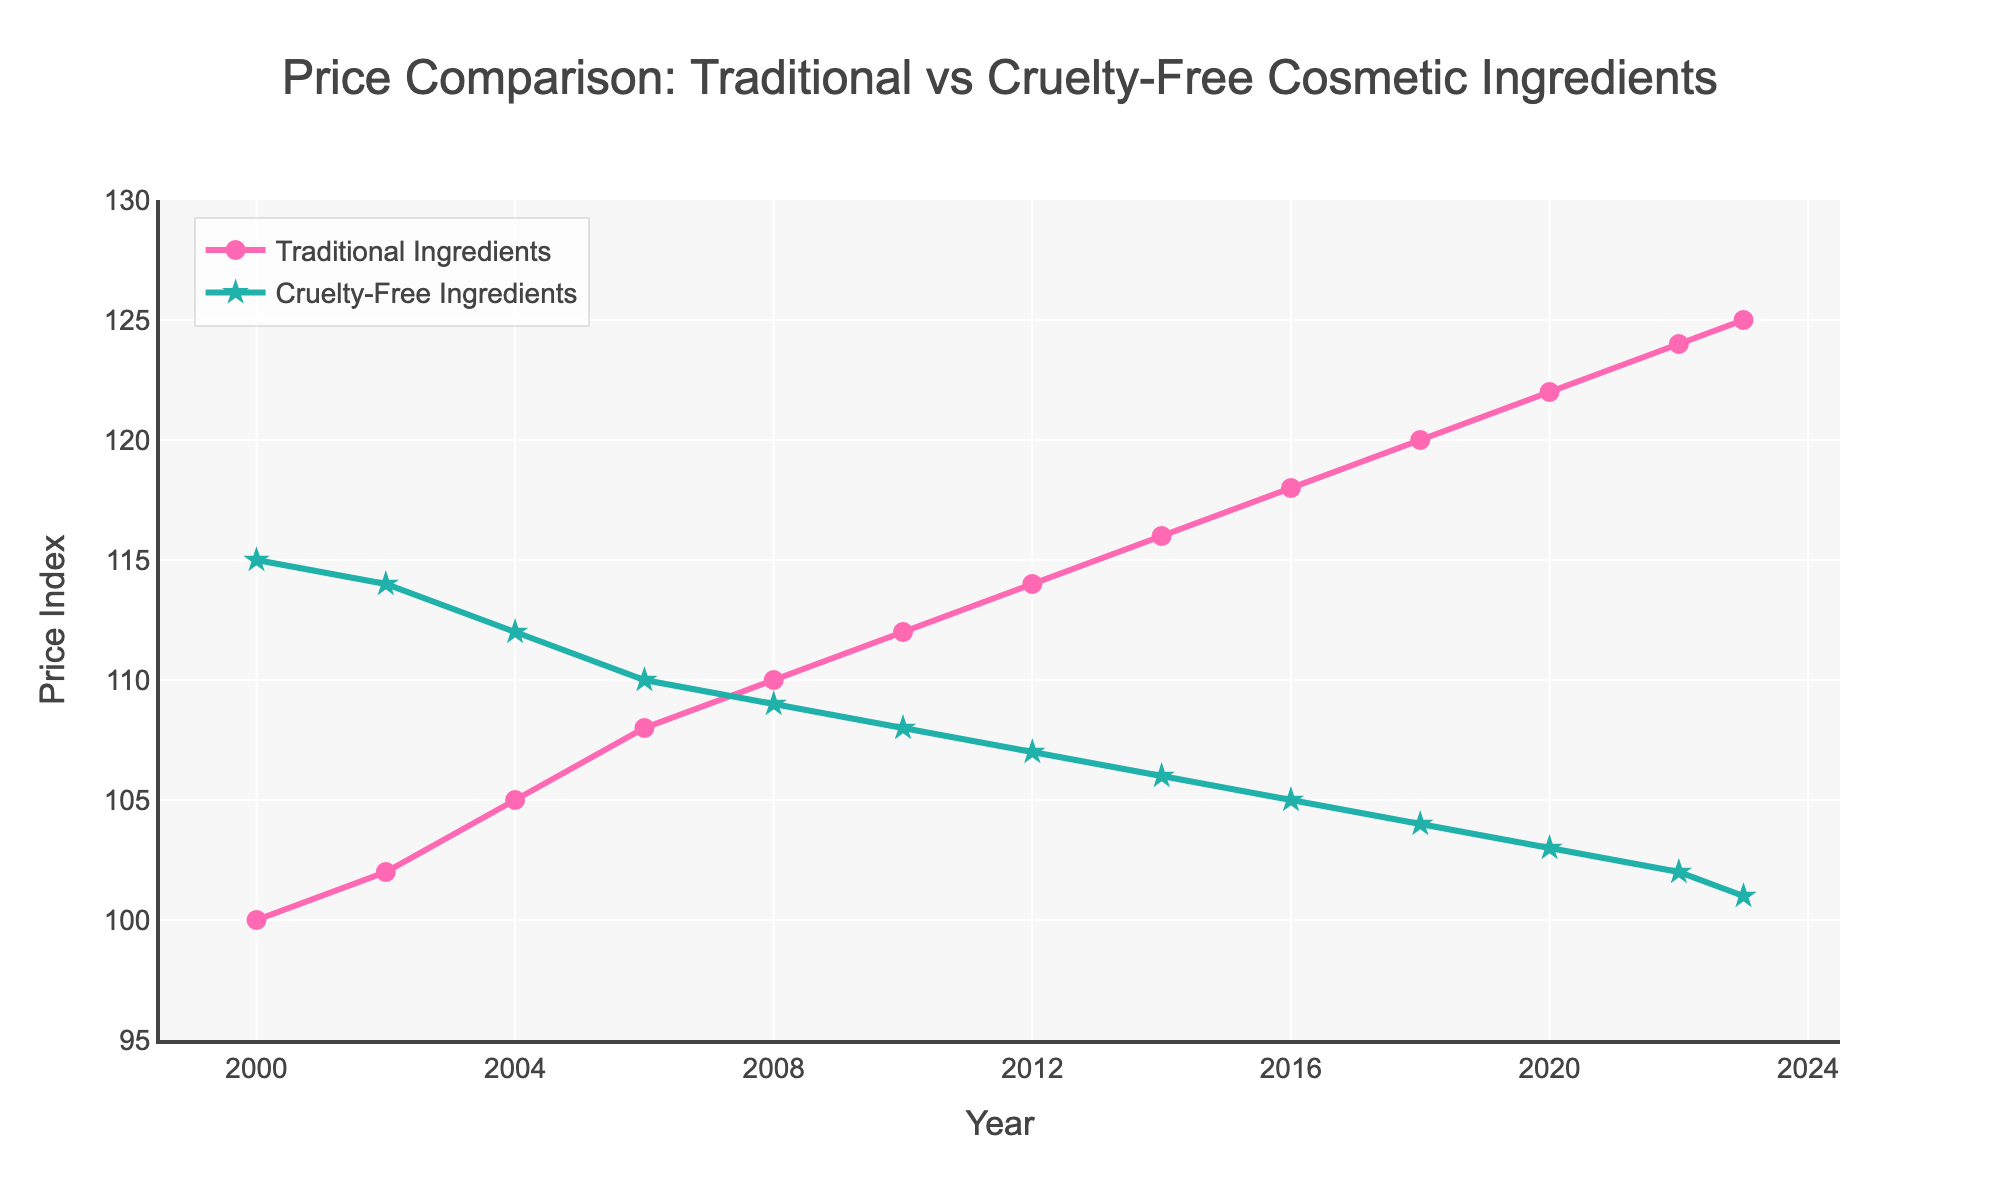What year did the price of cruelty-free ingredients drop below the price of traditional ingredients? The price of cruelty-free ingredients drops below the price of traditional ingredients in 2008, where the price index for cruelty-free ingredients is 109, and for traditional ingredients is 110.
Answer: 2008 In which year did the cruelty-free ingredients have the greatest difference in price compared to traditional ingredients? To find the year with the greatest difference, we subtract the cruelty-free price from the traditional price for each year and identify the maximum difference. The year 2000 shows the greatest difference, with traditional at 100 and cruelty-free at 115, a difference of 15.
Answer: 2000 How many years do the prices for traditional ingredients increase without decrease? The data shows a continuous increase in the prices of traditional ingredients from 2000 (100) to 2023 (125) without any decrease.
Answer: 24 years Which line (traditional or cruelty-free) shows a decreasing trend? The cruelty-free ingredients line shows a decreasing trend from 2000 (115) to 2023 (101).
Answer: Cruelty-free What is the price index difference between traditional and cruelty-free ingredients in 2023? The price index for traditional ingredients in 2023 is 125 and for cruelty-free ingredients is 101. The difference is 125 - 101 = 24.
Answer: 24 Does the price index for cruelty-free ingredients ever become equal to or higher than that of traditional ingredients after 2000? After 2000, the price index for cruelty-free ingredients never becomes equal to or higher than that of traditional ingredients. We see a continuous gap where traditional ingredients always have a higher price index.
Answer: No Which ingredient type shows more price stability over the years? By observing the trend lines, cruelty-free ingredients show a more stable and consistent drop without fluctuations, while traditional ingredients show a steady increase. Stability is better defined by the consistent trend without sharp changes.
Answer: Cruelty-free How many times did the prices for traditional ingredients surpass 120? The prices for traditional ingredients surpass 120 in the years 2020 (122), 2022 (124), and 2023 (125). This occurs three times.
Answer: 3 